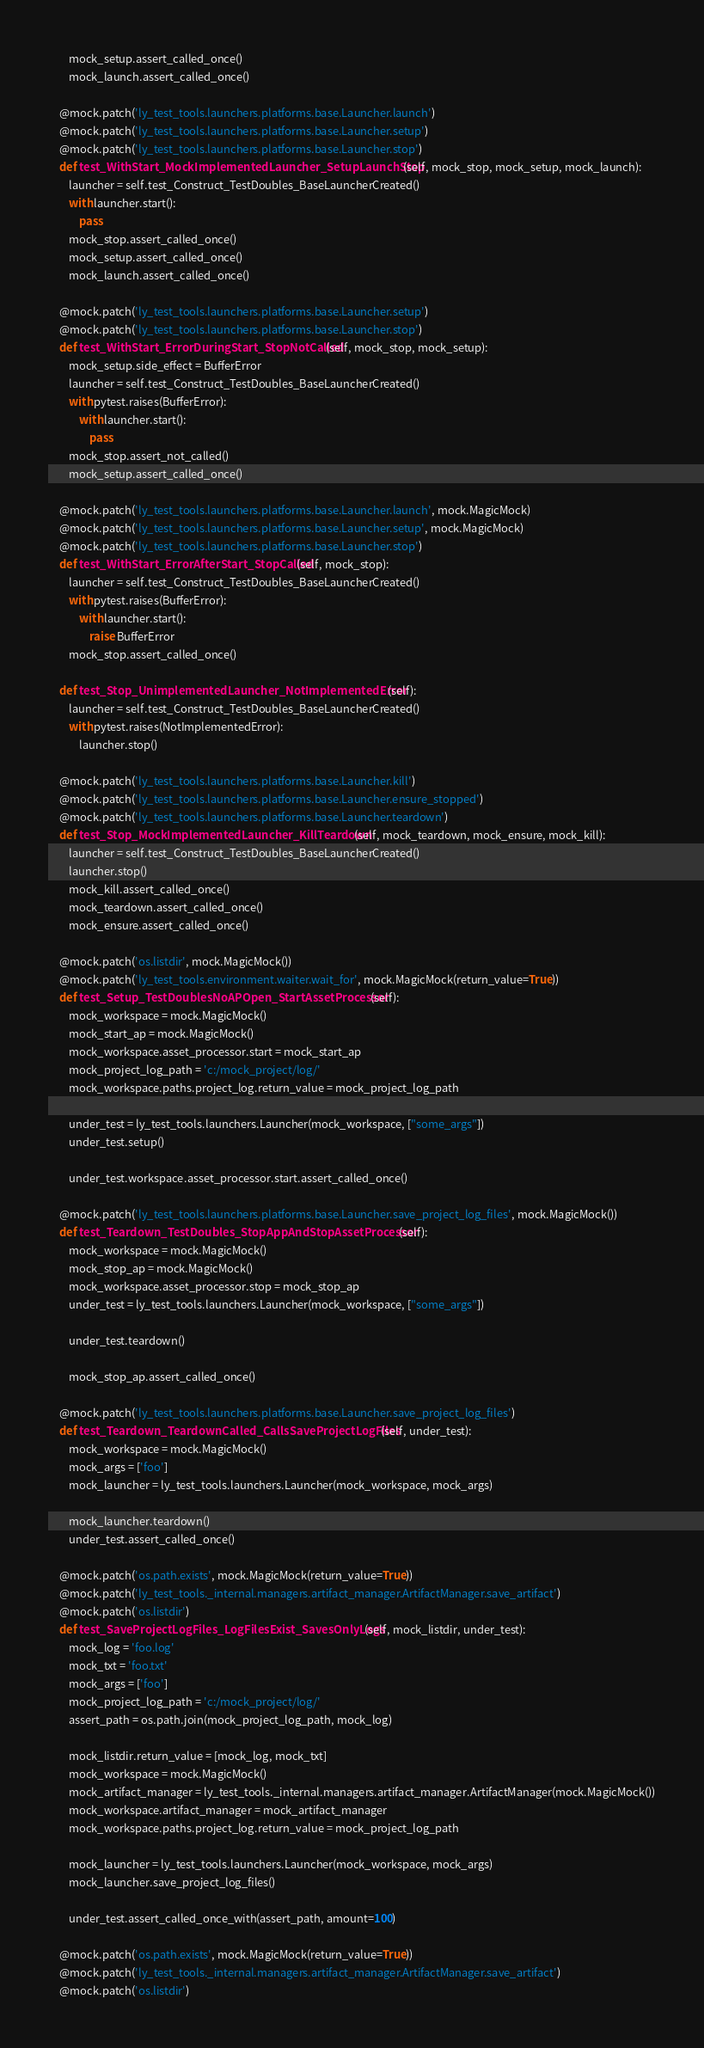<code> <loc_0><loc_0><loc_500><loc_500><_Python_>        mock_setup.assert_called_once()
        mock_launch.assert_called_once()

    @mock.patch('ly_test_tools.launchers.platforms.base.Launcher.launch')
    @mock.patch('ly_test_tools.launchers.platforms.base.Launcher.setup')
    @mock.patch('ly_test_tools.launchers.platforms.base.Launcher.stop')
    def test_WithStart_MockImplementedLauncher_SetupLaunchStop(self, mock_stop, mock_setup, mock_launch):
        launcher = self.test_Construct_TestDoubles_BaseLauncherCreated()
        with launcher.start():
            pass
        mock_stop.assert_called_once()
        mock_setup.assert_called_once()
        mock_launch.assert_called_once()

    @mock.patch('ly_test_tools.launchers.platforms.base.Launcher.setup')
    @mock.patch('ly_test_tools.launchers.platforms.base.Launcher.stop')
    def test_WithStart_ErrorDuringStart_StopNotCalled(self, mock_stop, mock_setup):
        mock_setup.side_effect = BufferError
        launcher = self.test_Construct_TestDoubles_BaseLauncherCreated()
        with pytest.raises(BufferError):
            with launcher.start():
                pass
        mock_stop.assert_not_called()
        mock_setup.assert_called_once()

    @mock.patch('ly_test_tools.launchers.platforms.base.Launcher.launch', mock.MagicMock)
    @mock.patch('ly_test_tools.launchers.platforms.base.Launcher.setup', mock.MagicMock)
    @mock.patch('ly_test_tools.launchers.platforms.base.Launcher.stop')
    def test_WithStart_ErrorAfterStart_StopCalled(self, mock_stop):
        launcher = self.test_Construct_TestDoubles_BaseLauncherCreated()
        with pytest.raises(BufferError):
            with launcher.start():
                raise BufferError
        mock_stop.assert_called_once()

    def test_Stop_UnimplementedLauncher_NotImplementedError(self):
        launcher = self.test_Construct_TestDoubles_BaseLauncherCreated()
        with pytest.raises(NotImplementedError):
            launcher.stop()

    @mock.patch('ly_test_tools.launchers.platforms.base.Launcher.kill')
    @mock.patch('ly_test_tools.launchers.platforms.base.Launcher.ensure_stopped')
    @mock.patch('ly_test_tools.launchers.platforms.base.Launcher.teardown')
    def test_Stop_MockImplementedLauncher_KillTeardown(self, mock_teardown, mock_ensure, mock_kill):
        launcher = self.test_Construct_TestDoubles_BaseLauncherCreated()
        launcher.stop()
        mock_kill.assert_called_once()
        mock_teardown.assert_called_once()
        mock_ensure.assert_called_once()

    @mock.patch('os.listdir', mock.MagicMock())
    @mock.patch('ly_test_tools.environment.waiter.wait_for', mock.MagicMock(return_value=True))
    def test_Setup_TestDoublesNoAPOpen_StartAssetProcessor(self):
        mock_workspace = mock.MagicMock()
        mock_start_ap = mock.MagicMock()
        mock_workspace.asset_processor.start = mock_start_ap
        mock_project_log_path = 'c:/mock_project/log/'
        mock_workspace.paths.project_log.return_value = mock_project_log_path

        under_test = ly_test_tools.launchers.Launcher(mock_workspace, ["some_args"])
        under_test.setup()

        under_test.workspace.asset_processor.start.assert_called_once()

    @mock.patch('ly_test_tools.launchers.platforms.base.Launcher.save_project_log_files', mock.MagicMock())
    def test_Teardown_TestDoubles_StopAppAndStopAssetProcessor(self):
        mock_workspace = mock.MagicMock()
        mock_stop_ap = mock.MagicMock()
        mock_workspace.asset_processor.stop = mock_stop_ap
        under_test = ly_test_tools.launchers.Launcher(mock_workspace, ["some_args"])

        under_test.teardown()

        mock_stop_ap.assert_called_once()

    @mock.patch('ly_test_tools.launchers.platforms.base.Launcher.save_project_log_files')
    def test_Teardown_TeardownCalled_CallsSaveProjectLogFiles(self, under_test):
        mock_workspace = mock.MagicMock()
        mock_args = ['foo']
        mock_launcher = ly_test_tools.launchers.Launcher(mock_workspace, mock_args)

        mock_launcher.teardown()
        under_test.assert_called_once()

    @mock.patch('os.path.exists', mock.MagicMock(return_value=True))
    @mock.patch('ly_test_tools._internal.managers.artifact_manager.ArtifactManager.save_artifact')
    @mock.patch('os.listdir')
    def test_SaveProjectLogFiles_LogFilesExist_SavesOnlyLogs(self, mock_listdir, under_test):
        mock_log = 'foo.log'
        mock_txt = 'foo.txt'
        mock_args = ['foo']
        mock_project_log_path = 'c:/mock_project/log/'
        assert_path = os.path.join(mock_project_log_path, mock_log)

        mock_listdir.return_value = [mock_log, mock_txt]
        mock_workspace = mock.MagicMock()
        mock_artifact_manager = ly_test_tools._internal.managers.artifact_manager.ArtifactManager(mock.MagicMock())
        mock_workspace.artifact_manager = mock_artifact_manager
        mock_workspace.paths.project_log.return_value = mock_project_log_path

        mock_launcher = ly_test_tools.launchers.Launcher(mock_workspace, mock_args)
        mock_launcher.save_project_log_files()

        under_test.assert_called_once_with(assert_path, amount=100)

    @mock.patch('os.path.exists', mock.MagicMock(return_value=True))
    @mock.patch('ly_test_tools._internal.managers.artifact_manager.ArtifactManager.save_artifact')
    @mock.patch('os.listdir')</code> 